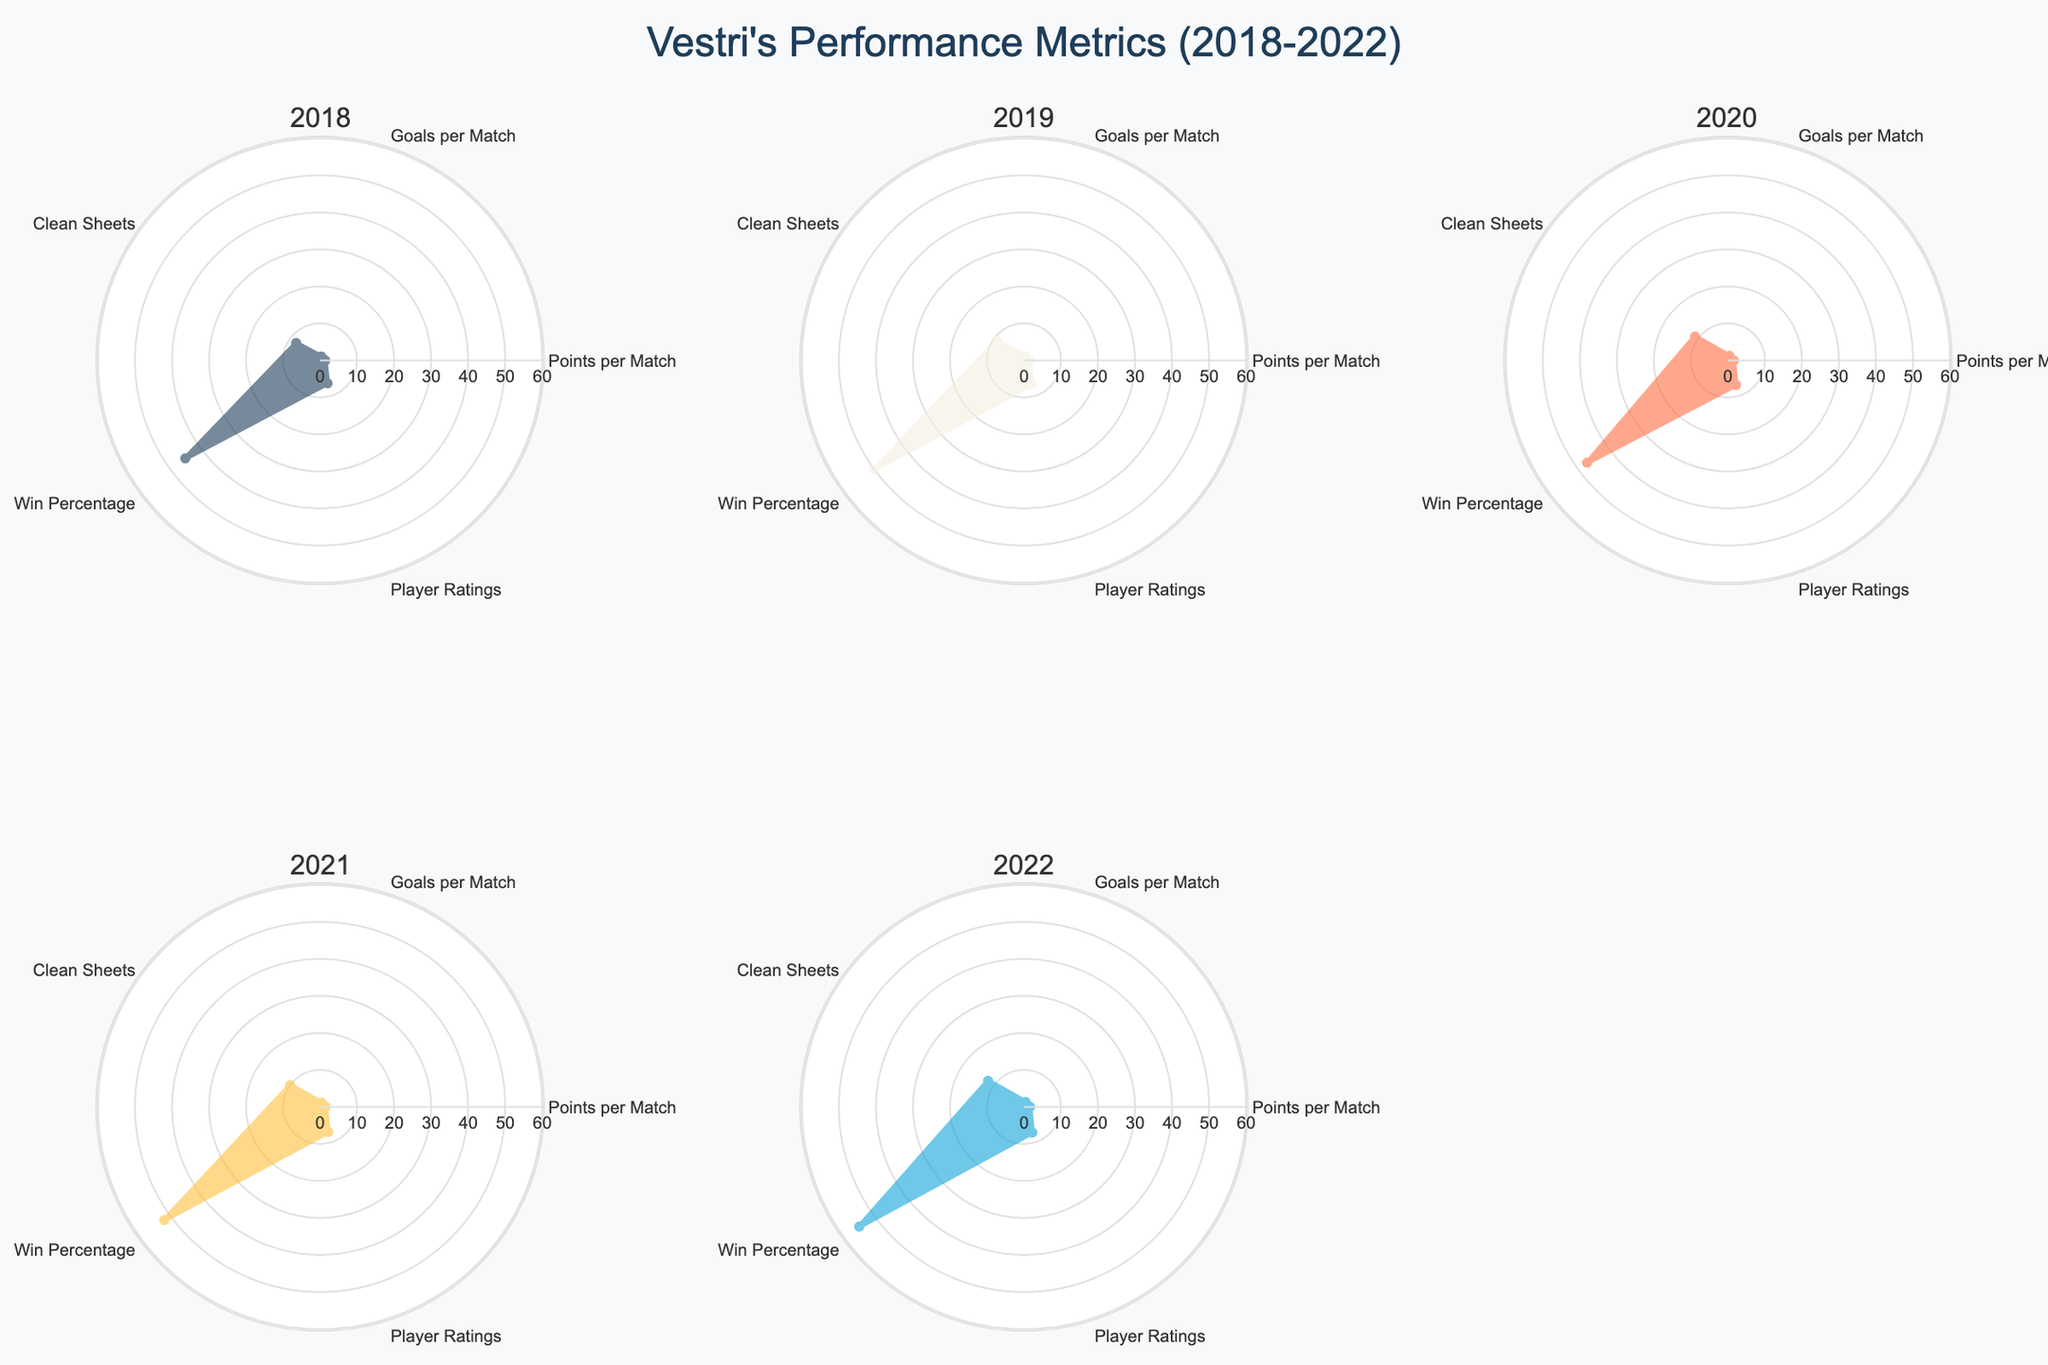What is the title of the figure? The title is displayed at the top center of the figure, which reads "Vestri's Performance Metrics (2018-2022)".
Answer: Vestri's Performance Metrics (2018-2022) How many subplots are in the figure? The figure consists of 6 subplots arranged in a 2x3 grid, one for each year from 2018 to 2022.
Answer: 6 Which year had the highest number of clean sheets? By examining the clean sheets metric in each subplot, the year 2022 shows the highest number of clean sheets.
Answer: 2022 What is the trend in Win Percentage from 2018 to 2022? By following the Win Percentage metric across subplots from 2018 to 2022, we can observe an increasing trend in win percentage over these years.
Answer: Increasing How does the average Player Rating change from 2018 to 2022? To find the average Player Rating from 2018 to 2022, note the values for each year: 6.5, 6.8, 7.0, 7.1, and 7.3. This demonstrates a steady upward trend in player ratings over the years.
Answer: Steady increase In which year was the Points per Match the highest? By examining the Points per Match metric across all subplots, the highest value is seen in the year 2022.
Answer: 2022 What is the general shape of the radar plot for Goals per Match from 2018 to 2022? The radar plot for Goals per Match shows a steady and incremental increase when reviewing each year's subplot from 2018 to 2022.
Answer: Gradual increase How does the Win Percentage for 2020 compare to 2019? By comparing the subplots for 2019 and 2020, note that 2020's Win Percentage is slightly less than in 2019.
Answer: Slightly lower Which metric displays the most consistent improvement from 2018 to 2022 across all subplots? Observing each subplot, Player Ratings show the most consistent improvement across these years, with values progressively increasing every year.
Answer: Player Ratings What can be observed about Vestri's Clean Sheets metric from 2018 to 2022? The trend for Clean Sheets starts at 8 in 2018 and shows a general increase each year, culminating at 12 in 2022, indicating a positive trend.
Answer: Positive trend 